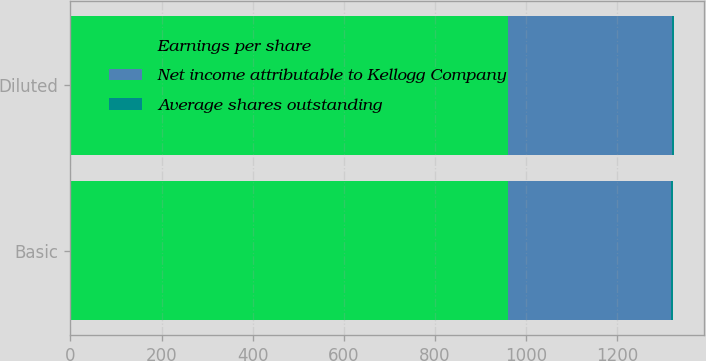Convert chart to OTSL. <chart><loc_0><loc_0><loc_500><loc_500><stacked_bar_chart><ecel><fcel>Basic<fcel>Diluted<nl><fcel>Earnings per share<fcel>961<fcel>961<nl><fcel>Net income attributable to Kellogg Company<fcel>358<fcel>360<nl><fcel>Average shares outstanding<fcel>2.68<fcel>2.67<nl></chart> 